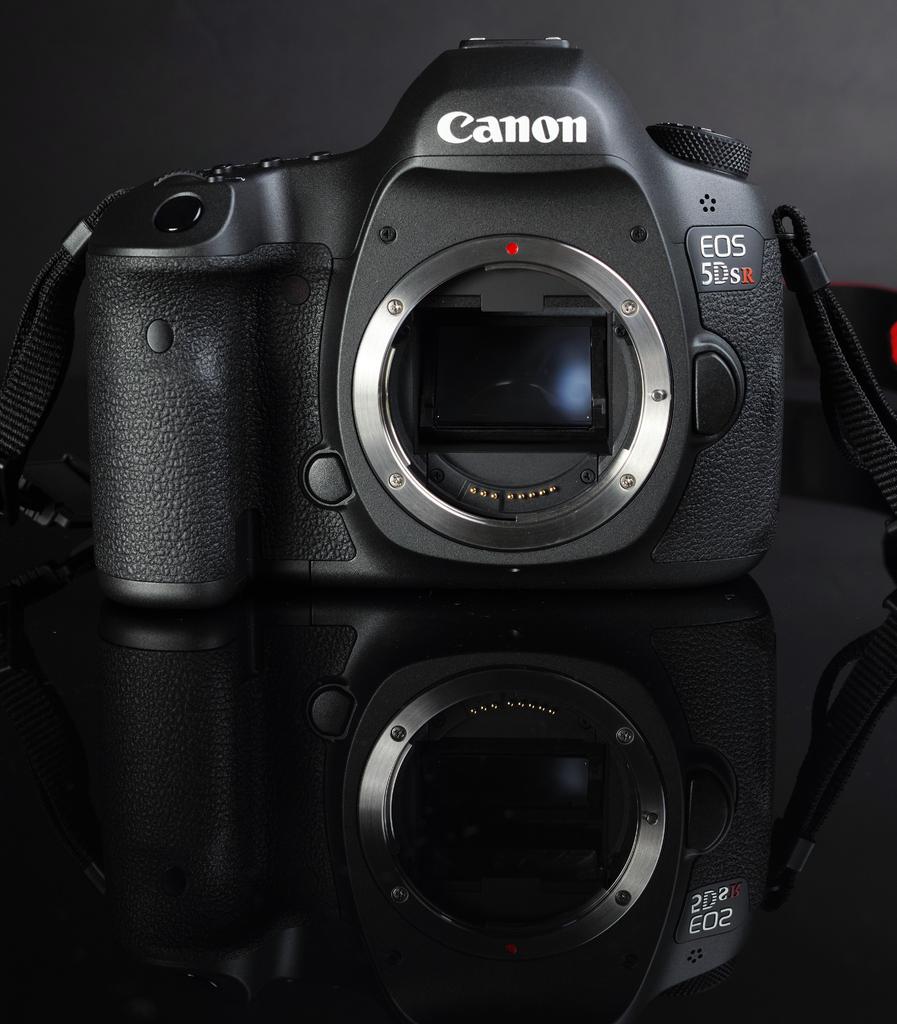What brand of camera is this?
Make the answer very short. Canon. 